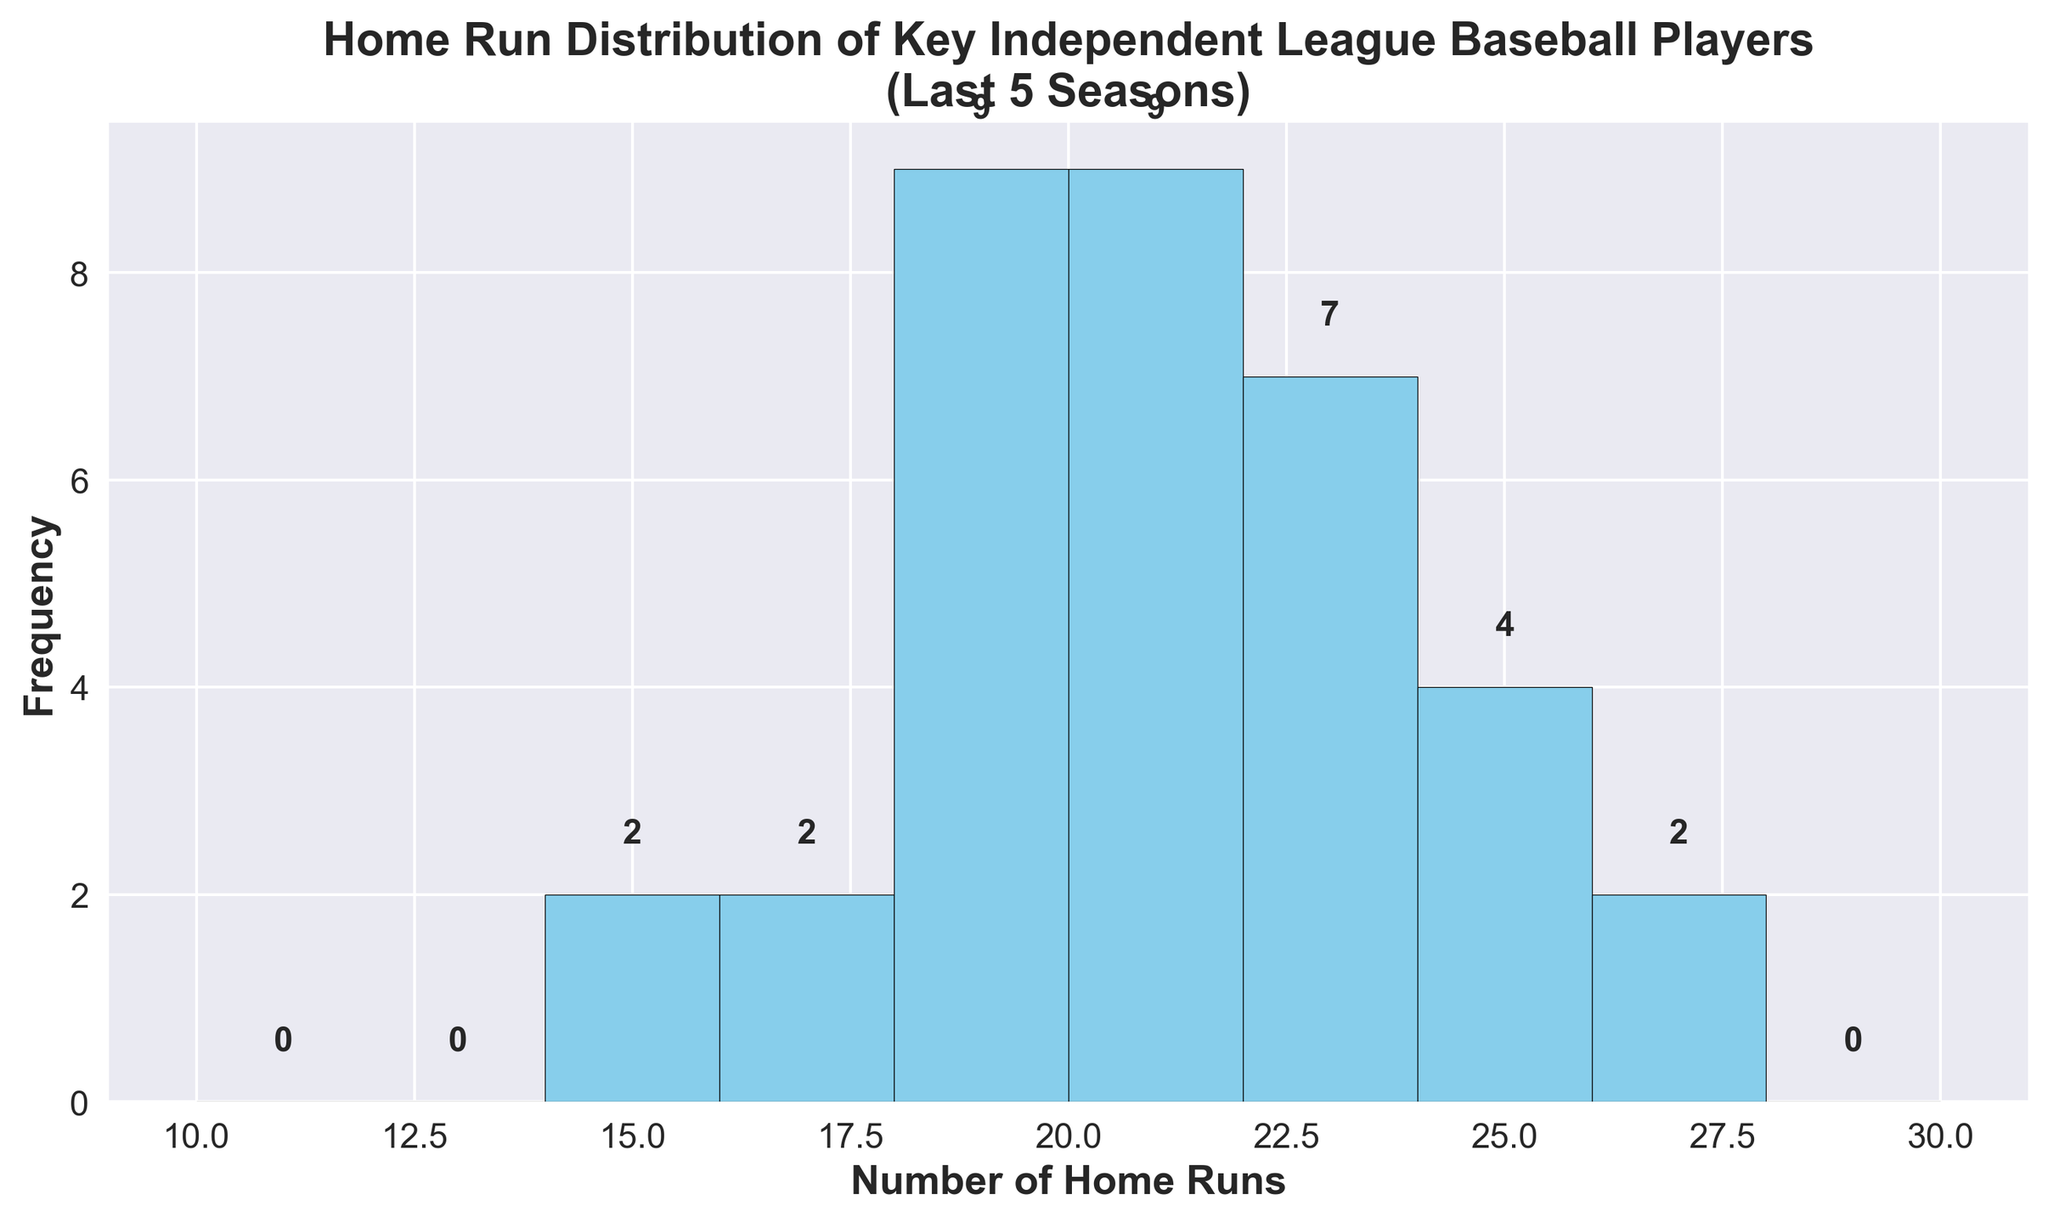What range of home runs has the highest frequency? Looking at the histogram, identify the bin with the tallest bar. This represents the range of home runs scored most frequently.
Answer: 22-23 How many players hit between 18 and 19 home runs? Sum up the frequencies of bars within the 18-19 range in the histogram. Count the number of high points shown in the bin for 18-19.
Answer: 6 Which range of home runs has the lowest frequency? Identify the shortest bar in the histogram. This bar represents the range of home runs scored least frequently.
Answer: 12-13 How many bins show a frequency greater than or equal to 5? Count the number of bars in the histogram that have a height of 5 or more.
Answer: 6 What is the total number of players who hit between 22 and 27 home runs? Add up the frequencies of the bins corresponding to the range 22 to 27.
Answer: 14 Which bin is higher: the bin for 20-21 home runs or the bin for 24-25 home runs? Compare the heights of the bars for the ranges 20-21 and 24-25.
Answer: 20-21 home runs What is the average number of home runs per player over these seasons? Sum all the values in the 'HomeRuns' column and divide by the total number of data points. (23+18+27+19+24+15+22+20+21+18+19+25+23+22+20+14+20+19+17+21+21+24+26+25+22+18+19+21+20 = 480; 480/30 = 16).
Answer: 20 How many players had a home run count of exactly 19 across the five seasons? Count the number of bars that cover the 19 home run mark in the histogram.
Answer: 4 Is the frequency of players hitting over 24 home runs higher than those hitting below 14 home runs? Compare the total frequency of bins for more than 24 home runs to the total frequency of bins for below 14 home runs.
Answer: Yes How many players hit between 10 and 20 home runs inclusive? Sum up the frequencies of the bins within the range 10-20.
Answer: 10 